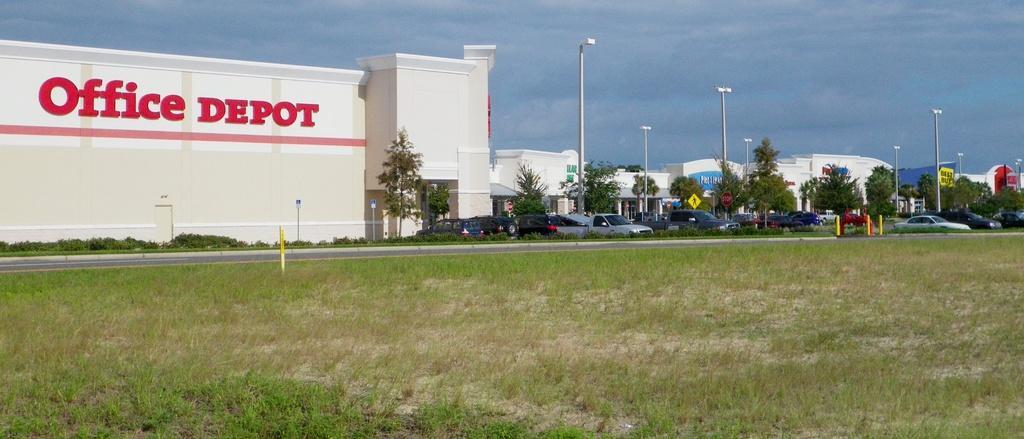How would you summarize this image in a sentence or two? In this image there are buildings, trees and cars parked on the ground. There is text on a building. In front of the cars there is a road. At the bottom there is grass on the ground. There are street light poles near to the buildings. At the top there is the sky. 